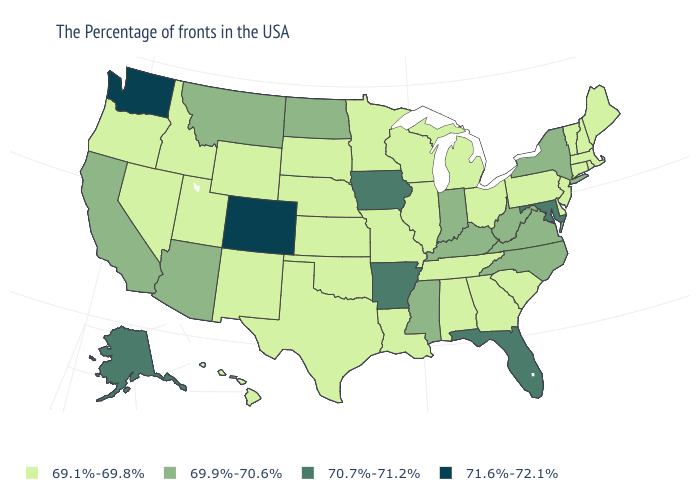What is the highest value in the USA?
Be succinct. 71.6%-72.1%. What is the value of New Mexico?
Give a very brief answer. 69.1%-69.8%. Does North Carolina have a lower value than New York?
Give a very brief answer. No. What is the value of Georgia?
Write a very short answer. 69.1%-69.8%. Among the states that border Connecticut , does Massachusetts have the lowest value?
Concise answer only. Yes. Is the legend a continuous bar?
Quick response, please. No. What is the highest value in the USA?
Write a very short answer. 71.6%-72.1%. What is the value of Maine?
Write a very short answer. 69.1%-69.8%. Which states have the lowest value in the USA?
Be succinct. Maine, Massachusetts, Rhode Island, New Hampshire, Vermont, Connecticut, New Jersey, Delaware, Pennsylvania, South Carolina, Ohio, Georgia, Michigan, Alabama, Tennessee, Wisconsin, Illinois, Louisiana, Missouri, Minnesota, Kansas, Nebraska, Oklahoma, Texas, South Dakota, Wyoming, New Mexico, Utah, Idaho, Nevada, Oregon, Hawaii. What is the value of Utah?
Answer briefly. 69.1%-69.8%. Name the states that have a value in the range 69.1%-69.8%?
Give a very brief answer. Maine, Massachusetts, Rhode Island, New Hampshire, Vermont, Connecticut, New Jersey, Delaware, Pennsylvania, South Carolina, Ohio, Georgia, Michigan, Alabama, Tennessee, Wisconsin, Illinois, Louisiana, Missouri, Minnesota, Kansas, Nebraska, Oklahoma, Texas, South Dakota, Wyoming, New Mexico, Utah, Idaho, Nevada, Oregon, Hawaii. What is the highest value in the South ?
Keep it brief. 70.7%-71.2%. What is the lowest value in the USA?
Be succinct. 69.1%-69.8%. What is the lowest value in the MidWest?
Quick response, please. 69.1%-69.8%. How many symbols are there in the legend?
Concise answer only. 4. 